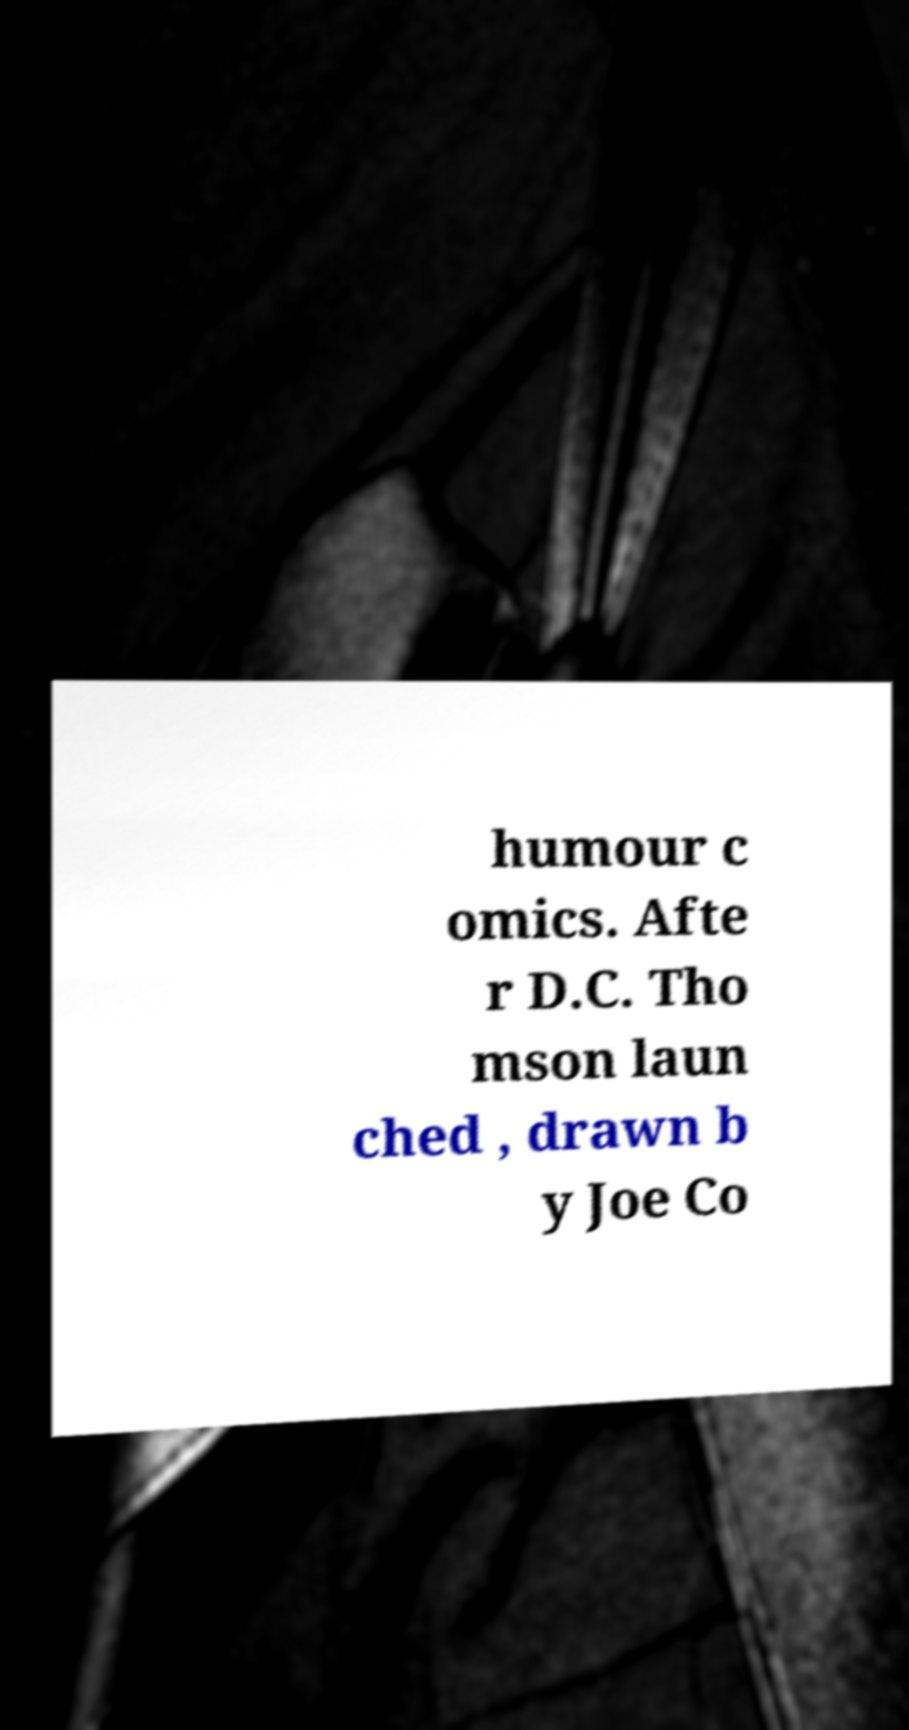There's text embedded in this image that I need extracted. Can you transcribe it verbatim? humour c omics. Afte r D.C. Tho mson laun ched , drawn b y Joe Co 